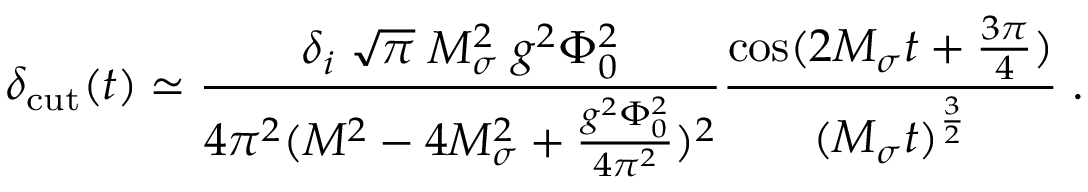Convert formula to latex. <formula><loc_0><loc_0><loc_500><loc_500>\delta _ { c u t } ( t ) \simeq { \frac { \delta _ { i } \, \sqrt { \pi } \, M _ { \sigma } ^ { 2 } \, g ^ { 2 } \Phi _ { 0 } ^ { 2 } } { 4 \pi ^ { 2 } ( M ^ { 2 } - 4 M _ { \sigma } ^ { 2 } + { \frac { g ^ { 2 } \Phi _ { 0 } ^ { 2 } } { 4 \pi ^ { 2 } } } ) ^ { 2 } } } { \frac { \cos ( 2 M _ { \sigma } t + { \frac { 3 \pi } { 4 } } ) } { ( M _ { \sigma } t ) ^ { \frac { 3 } { 2 } } } } \, .</formula> 